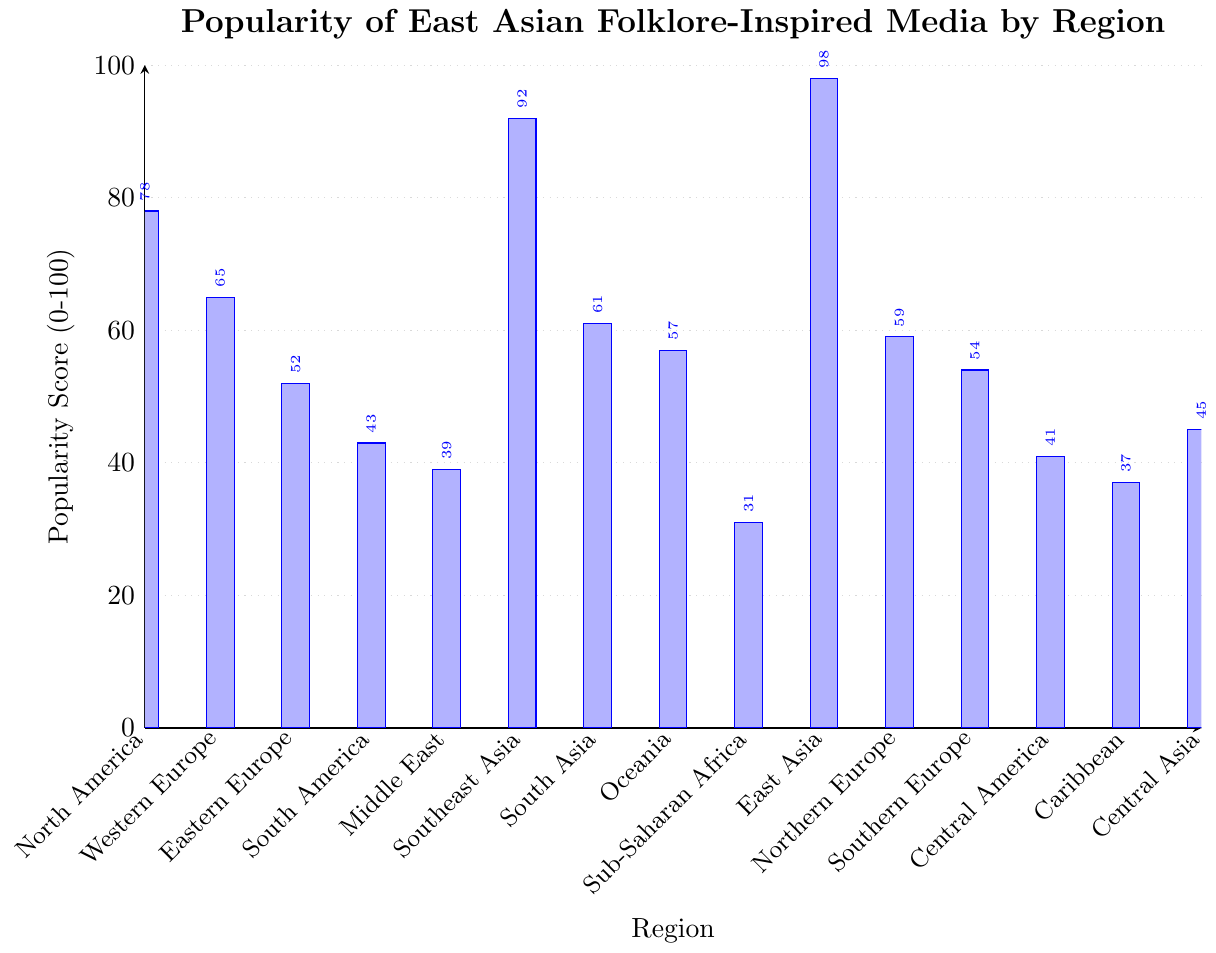what region has the highest popularity score? The tallest bar in the figure represents the region with the highest popularity score. The bar for East Asia is the highest, indicating that it has the highest popularity score.
Answer: East Asia what is the difference in popularity scores between East Asia and North America? The bar for East Asia has a height of 98, while the bar for North America is 78. Subtract the North America score from the East Asia score to find the difference. 98 - 78 = 20
Answer: 20 how does the popularity score for Southeast Asia compare to South America? The height of the bar for Southeast Asia is 92, while the bar for South America is 43. Southeast Asia has a higher popularity score.
Answer: Southeast Asia is higher Which regions have popularity scores below 40? The bars representing regions with popularity scores below 40 include the Middle East (39), Sub-Saharan Africa (31), Caribbean (37).
Answer: Middle East, Sub-Saharan Africa, Caribbean what is the average popularity score of Southeastern Europe, Central America, and the Caribbean? The scores for the three regions are Southern Europe 54, Central America 41, and Caribbean 37. Add these scores and divide by the number of regions: (54 + 41 + 37) / 3 = 44
Answer: 44 which region has a slightly higher popularity score, Northern Europe or Oceania? The bar for Northern Europe has a score of 59, while the bar for Oceania has a score of 57. Northern Europe has a slightly higher popularity score.
Answer: Northern Europe what's the total popularity score for all regions combined? Sum up the popularity scores of all regions: 78 + 65 + 52 + 43 + 39 + 92 + 61 + 57 + 31 + 98 + 59 + 54 + 41 + 37 + 45 = 852
Answer: 852 what is the median popularity score of the regions? List the popularity scores in ascending order: 31, 37, 39, 41, 43, 45, 52, 54, 57, 59, 61, 65, 78, 92, 98. Since there are 15 scores, the median is the 8th value in this ordered list, which is 54
Answer: 54 